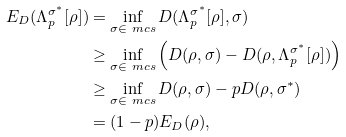<formula> <loc_0><loc_0><loc_500><loc_500>E _ { D } ( \Lambda ^ { \sigma ^ { * } } _ { p } [ \rho ] ) & = \inf _ { \sigma \in \ m c s } D ( \Lambda ^ { \sigma ^ { * } } _ { p } [ \rho ] , \sigma ) \\ & \geq \inf _ { \sigma \in \ m c s } \left ( D ( \rho , \sigma ) - D ( \rho , \Lambda ^ { \sigma ^ { * } } _ { p } [ \rho ] ) \right ) \\ & \geq \inf _ { \sigma \in \ m c s } D ( \rho , \sigma ) - p D ( \rho , \sigma ^ { * } ) \\ & = ( 1 - p ) E _ { D } ( \rho ) ,</formula> 